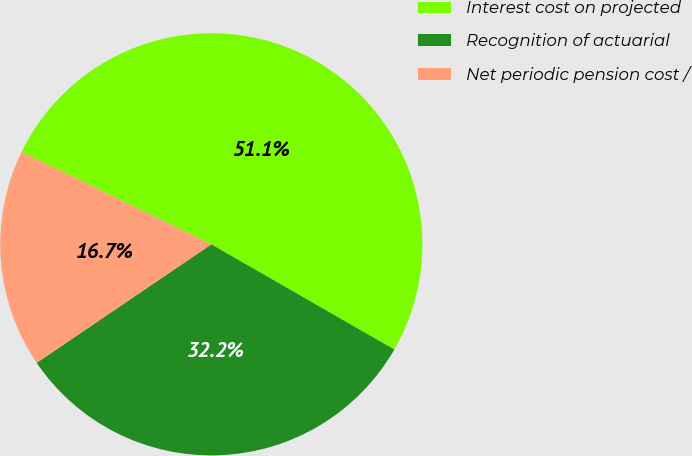Convert chart to OTSL. <chart><loc_0><loc_0><loc_500><loc_500><pie_chart><fcel>Interest cost on projected<fcel>Recognition of actuarial<fcel>Net periodic pension cost /<nl><fcel>51.08%<fcel>32.21%<fcel>16.71%<nl></chart> 